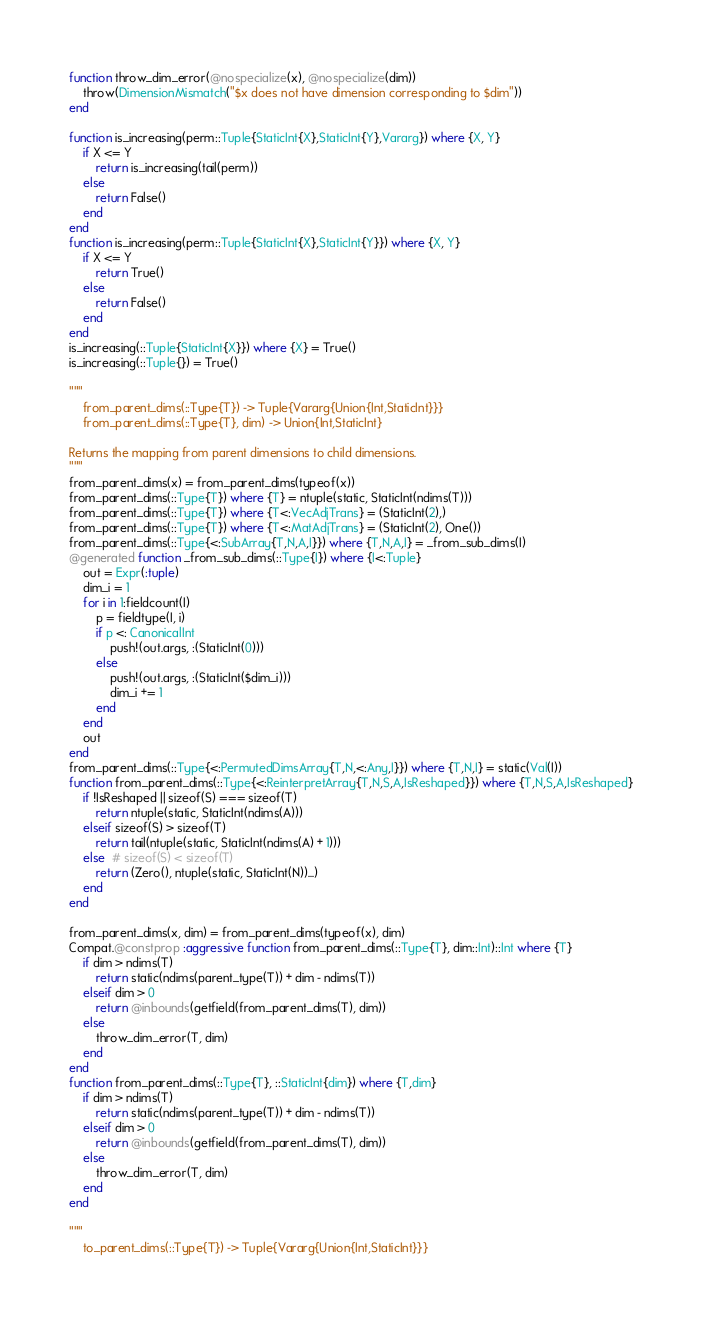<code> <loc_0><loc_0><loc_500><loc_500><_Julia_>
function throw_dim_error(@nospecialize(x), @nospecialize(dim))
    throw(DimensionMismatch("$x does not have dimension corresponding to $dim"))
end

function is_increasing(perm::Tuple{StaticInt{X},StaticInt{Y},Vararg}) where {X, Y}
    if X <= Y
        return is_increasing(tail(perm))
    else
        return False()
    end
end
function is_increasing(perm::Tuple{StaticInt{X},StaticInt{Y}}) where {X, Y}
    if X <= Y
        return True()
    else
        return False()
    end
end
is_increasing(::Tuple{StaticInt{X}}) where {X} = True()
is_increasing(::Tuple{}) = True()

"""
    from_parent_dims(::Type{T}) -> Tuple{Vararg{Union{Int,StaticInt}}}
    from_parent_dims(::Type{T}, dim) -> Union{Int,StaticInt}

Returns the mapping from parent dimensions to child dimensions.
"""
from_parent_dims(x) = from_parent_dims(typeof(x))
from_parent_dims(::Type{T}) where {T} = ntuple(static, StaticInt(ndims(T)))
from_parent_dims(::Type{T}) where {T<:VecAdjTrans} = (StaticInt(2),)
from_parent_dims(::Type{T}) where {T<:MatAdjTrans} = (StaticInt(2), One())
from_parent_dims(::Type{<:SubArray{T,N,A,I}}) where {T,N,A,I} = _from_sub_dims(I)
@generated function _from_sub_dims(::Type{I}) where {I<:Tuple}
    out = Expr(:tuple)
    dim_i = 1
    for i in 1:fieldcount(I)
        p = fieldtype(I, i)
        if p <: CanonicalInt
            push!(out.args, :(StaticInt(0)))
        else
            push!(out.args, :(StaticInt($dim_i)))
            dim_i += 1
        end
    end
    out
end
from_parent_dims(::Type{<:PermutedDimsArray{T,N,<:Any,I}}) where {T,N,I} = static(Val(I))
function from_parent_dims(::Type{<:ReinterpretArray{T,N,S,A,IsReshaped}}) where {T,N,S,A,IsReshaped}
    if !IsReshaped || sizeof(S) === sizeof(T)
        return ntuple(static, StaticInt(ndims(A)))
    elseif sizeof(S) > sizeof(T)
        return tail(ntuple(static, StaticInt(ndims(A) + 1)))
    else  # sizeof(S) < sizeof(T)
        return (Zero(), ntuple(static, StaticInt(N))...)
    end
end

from_parent_dims(x, dim) = from_parent_dims(typeof(x), dim)
Compat.@constprop :aggressive function from_parent_dims(::Type{T}, dim::Int)::Int where {T}
    if dim > ndims(T)
        return static(ndims(parent_type(T)) + dim - ndims(T))
    elseif dim > 0
        return @inbounds(getfield(from_parent_dims(T), dim))
    else
        throw_dim_error(T, dim)
    end
end
function from_parent_dims(::Type{T}, ::StaticInt{dim}) where {T,dim}
    if dim > ndims(T)
        return static(ndims(parent_type(T)) + dim - ndims(T))
    elseif dim > 0
        return @inbounds(getfield(from_parent_dims(T), dim))
    else
        throw_dim_error(T, dim)
    end
end

"""
    to_parent_dims(::Type{T}) -> Tuple{Vararg{Union{Int,StaticInt}}}</code> 